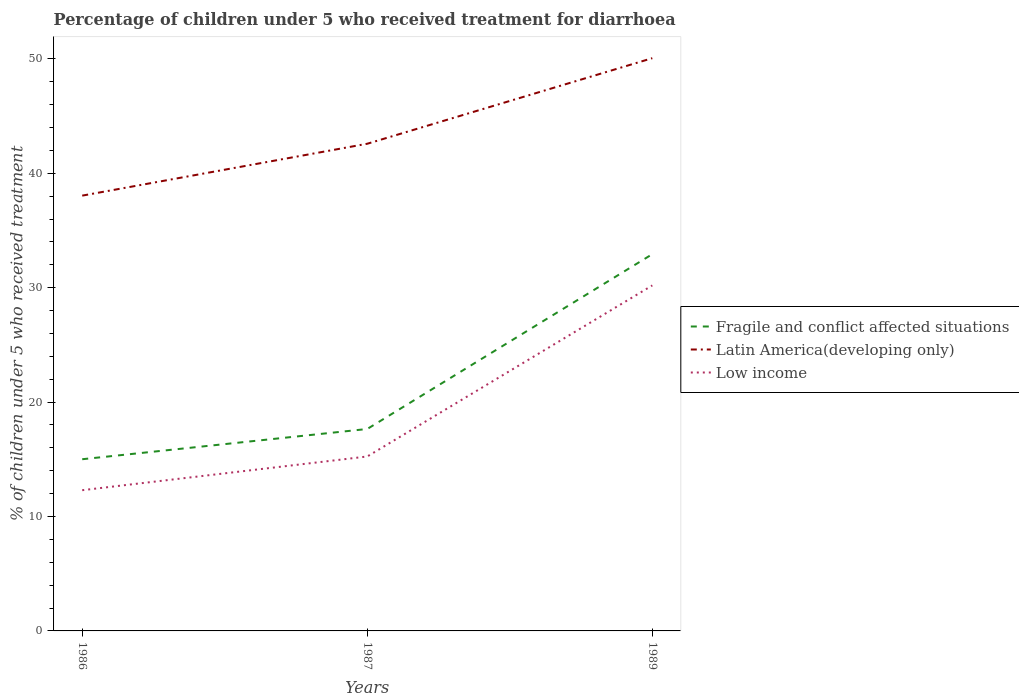How many different coloured lines are there?
Offer a very short reply. 3. Does the line corresponding to Latin America(developing only) intersect with the line corresponding to Fragile and conflict affected situations?
Provide a succinct answer. No. Across all years, what is the maximum percentage of children who received treatment for diarrhoea  in Latin America(developing only)?
Provide a short and direct response. 38.04. In which year was the percentage of children who received treatment for diarrhoea  in Fragile and conflict affected situations maximum?
Your answer should be very brief. 1986. What is the total percentage of children who received treatment for diarrhoea  in Fragile and conflict affected situations in the graph?
Keep it short and to the point. -2.64. What is the difference between the highest and the second highest percentage of children who received treatment for diarrhoea  in Low income?
Your response must be concise. 17.9. What is the difference between the highest and the lowest percentage of children who received treatment for diarrhoea  in Low income?
Your response must be concise. 1. Is the percentage of children who received treatment for diarrhoea  in Fragile and conflict affected situations strictly greater than the percentage of children who received treatment for diarrhoea  in Latin America(developing only) over the years?
Ensure brevity in your answer.  Yes. How many lines are there?
Your answer should be compact. 3. How many years are there in the graph?
Your response must be concise. 3. Are the values on the major ticks of Y-axis written in scientific E-notation?
Ensure brevity in your answer.  No. Where does the legend appear in the graph?
Your answer should be compact. Center right. What is the title of the graph?
Make the answer very short. Percentage of children under 5 who received treatment for diarrhoea. What is the label or title of the X-axis?
Offer a terse response. Years. What is the label or title of the Y-axis?
Keep it short and to the point. % of children under 5 who received treatment. What is the % of children under 5 who received treatment in Fragile and conflict affected situations in 1986?
Make the answer very short. 15.01. What is the % of children under 5 who received treatment in Latin America(developing only) in 1986?
Offer a very short reply. 38.04. What is the % of children under 5 who received treatment of Low income in 1986?
Give a very brief answer. 12.3. What is the % of children under 5 who received treatment of Fragile and conflict affected situations in 1987?
Offer a very short reply. 17.65. What is the % of children under 5 who received treatment in Latin America(developing only) in 1987?
Keep it short and to the point. 42.58. What is the % of children under 5 who received treatment of Low income in 1987?
Keep it short and to the point. 15.25. What is the % of children under 5 who received treatment of Fragile and conflict affected situations in 1989?
Give a very brief answer. 32.93. What is the % of children under 5 who received treatment of Latin America(developing only) in 1989?
Offer a terse response. 50.06. What is the % of children under 5 who received treatment in Low income in 1989?
Your response must be concise. 30.2. Across all years, what is the maximum % of children under 5 who received treatment in Fragile and conflict affected situations?
Provide a short and direct response. 32.93. Across all years, what is the maximum % of children under 5 who received treatment of Latin America(developing only)?
Make the answer very short. 50.06. Across all years, what is the maximum % of children under 5 who received treatment of Low income?
Your answer should be compact. 30.2. Across all years, what is the minimum % of children under 5 who received treatment in Fragile and conflict affected situations?
Keep it short and to the point. 15.01. Across all years, what is the minimum % of children under 5 who received treatment in Latin America(developing only)?
Your response must be concise. 38.04. Across all years, what is the minimum % of children under 5 who received treatment of Low income?
Provide a succinct answer. 12.3. What is the total % of children under 5 who received treatment of Fragile and conflict affected situations in the graph?
Give a very brief answer. 65.58. What is the total % of children under 5 who received treatment in Latin America(developing only) in the graph?
Your answer should be very brief. 130.68. What is the total % of children under 5 who received treatment in Low income in the graph?
Provide a succinct answer. 57.74. What is the difference between the % of children under 5 who received treatment of Fragile and conflict affected situations in 1986 and that in 1987?
Your answer should be very brief. -2.64. What is the difference between the % of children under 5 who received treatment in Latin America(developing only) in 1986 and that in 1987?
Give a very brief answer. -4.53. What is the difference between the % of children under 5 who received treatment of Low income in 1986 and that in 1987?
Offer a very short reply. -2.95. What is the difference between the % of children under 5 who received treatment in Fragile and conflict affected situations in 1986 and that in 1989?
Provide a short and direct response. -17.92. What is the difference between the % of children under 5 who received treatment of Latin America(developing only) in 1986 and that in 1989?
Your answer should be compact. -12.01. What is the difference between the % of children under 5 who received treatment in Low income in 1986 and that in 1989?
Offer a very short reply. -17.9. What is the difference between the % of children under 5 who received treatment in Fragile and conflict affected situations in 1987 and that in 1989?
Give a very brief answer. -15.28. What is the difference between the % of children under 5 who received treatment of Latin America(developing only) in 1987 and that in 1989?
Ensure brevity in your answer.  -7.48. What is the difference between the % of children under 5 who received treatment in Low income in 1987 and that in 1989?
Ensure brevity in your answer.  -14.95. What is the difference between the % of children under 5 who received treatment in Fragile and conflict affected situations in 1986 and the % of children under 5 who received treatment in Latin America(developing only) in 1987?
Provide a succinct answer. -27.57. What is the difference between the % of children under 5 who received treatment of Fragile and conflict affected situations in 1986 and the % of children under 5 who received treatment of Low income in 1987?
Your response must be concise. -0.24. What is the difference between the % of children under 5 who received treatment in Latin America(developing only) in 1986 and the % of children under 5 who received treatment in Low income in 1987?
Your response must be concise. 22.8. What is the difference between the % of children under 5 who received treatment of Fragile and conflict affected situations in 1986 and the % of children under 5 who received treatment of Latin America(developing only) in 1989?
Provide a short and direct response. -35.05. What is the difference between the % of children under 5 who received treatment in Fragile and conflict affected situations in 1986 and the % of children under 5 who received treatment in Low income in 1989?
Offer a terse response. -15.19. What is the difference between the % of children under 5 who received treatment in Latin America(developing only) in 1986 and the % of children under 5 who received treatment in Low income in 1989?
Ensure brevity in your answer.  7.85. What is the difference between the % of children under 5 who received treatment of Fragile and conflict affected situations in 1987 and the % of children under 5 who received treatment of Latin America(developing only) in 1989?
Keep it short and to the point. -32.41. What is the difference between the % of children under 5 who received treatment of Fragile and conflict affected situations in 1987 and the % of children under 5 who received treatment of Low income in 1989?
Make the answer very short. -12.55. What is the difference between the % of children under 5 who received treatment in Latin America(developing only) in 1987 and the % of children under 5 who received treatment in Low income in 1989?
Make the answer very short. 12.38. What is the average % of children under 5 who received treatment of Fragile and conflict affected situations per year?
Give a very brief answer. 21.86. What is the average % of children under 5 who received treatment in Latin America(developing only) per year?
Offer a very short reply. 43.56. What is the average % of children under 5 who received treatment in Low income per year?
Offer a terse response. 19.25. In the year 1986, what is the difference between the % of children under 5 who received treatment of Fragile and conflict affected situations and % of children under 5 who received treatment of Latin America(developing only)?
Make the answer very short. -23.04. In the year 1986, what is the difference between the % of children under 5 who received treatment of Fragile and conflict affected situations and % of children under 5 who received treatment of Low income?
Keep it short and to the point. 2.71. In the year 1986, what is the difference between the % of children under 5 who received treatment in Latin America(developing only) and % of children under 5 who received treatment in Low income?
Provide a succinct answer. 25.75. In the year 1987, what is the difference between the % of children under 5 who received treatment of Fragile and conflict affected situations and % of children under 5 who received treatment of Latin America(developing only)?
Provide a succinct answer. -24.93. In the year 1987, what is the difference between the % of children under 5 who received treatment of Fragile and conflict affected situations and % of children under 5 who received treatment of Low income?
Your answer should be very brief. 2.4. In the year 1987, what is the difference between the % of children under 5 who received treatment of Latin America(developing only) and % of children under 5 who received treatment of Low income?
Offer a very short reply. 27.33. In the year 1989, what is the difference between the % of children under 5 who received treatment in Fragile and conflict affected situations and % of children under 5 who received treatment in Latin America(developing only)?
Provide a short and direct response. -17.13. In the year 1989, what is the difference between the % of children under 5 who received treatment in Fragile and conflict affected situations and % of children under 5 who received treatment in Low income?
Ensure brevity in your answer.  2.73. In the year 1989, what is the difference between the % of children under 5 who received treatment of Latin America(developing only) and % of children under 5 who received treatment of Low income?
Offer a terse response. 19.86. What is the ratio of the % of children under 5 who received treatment in Fragile and conflict affected situations in 1986 to that in 1987?
Provide a succinct answer. 0.85. What is the ratio of the % of children under 5 who received treatment in Latin America(developing only) in 1986 to that in 1987?
Provide a short and direct response. 0.89. What is the ratio of the % of children under 5 who received treatment of Low income in 1986 to that in 1987?
Provide a short and direct response. 0.81. What is the ratio of the % of children under 5 who received treatment of Fragile and conflict affected situations in 1986 to that in 1989?
Provide a succinct answer. 0.46. What is the ratio of the % of children under 5 who received treatment in Latin America(developing only) in 1986 to that in 1989?
Your answer should be compact. 0.76. What is the ratio of the % of children under 5 who received treatment of Low income in 1986 to that in 1989?
Your answer should be compact. 0.41. What is the ratio of the % of children under 5 who received treatment of Fragile and conflict affected situations in 1987 to that in 1989?
Offer a very short reply. 0.54. What is the ratio of the % of children under 5 who received treatment of Latin America(developing only) in 1987 to that in 1989?
Your answer should be very brief. 0.85. What is the ratio of the % of children under 5 who received treatment in Low income in 1987 to that in 1989?
Provide a succinct answer. 0.5. What is the difference between the highest and the second highest % of children under 5 who received treatment in Fragile and conflict affected situations?
Make the answer very short. 15.28. What is the difference between the highest and the second highest % of children under 5 who received treatment of Latin America(developing only)?
Your response must be concise. 7.48. What is the difference between the highest and the second highest % of children under 5 who received treatment of Low income?
Make the answer very short. 14.95. What is the difference between the highest and the lowest % of children under 5 who received treatment in Fragile and conflict affected situations?
Keep it short and to the point. 17.92. What is the difference between the highest and the lowest % of children under 5 who received treatment of Latin America(developing only)?
Provide a short and direct response. 12.01. What is the difference between the highest and the lowest % of children under 5 who received treatment of Low income?
Offer a very short reply. 17.9. 